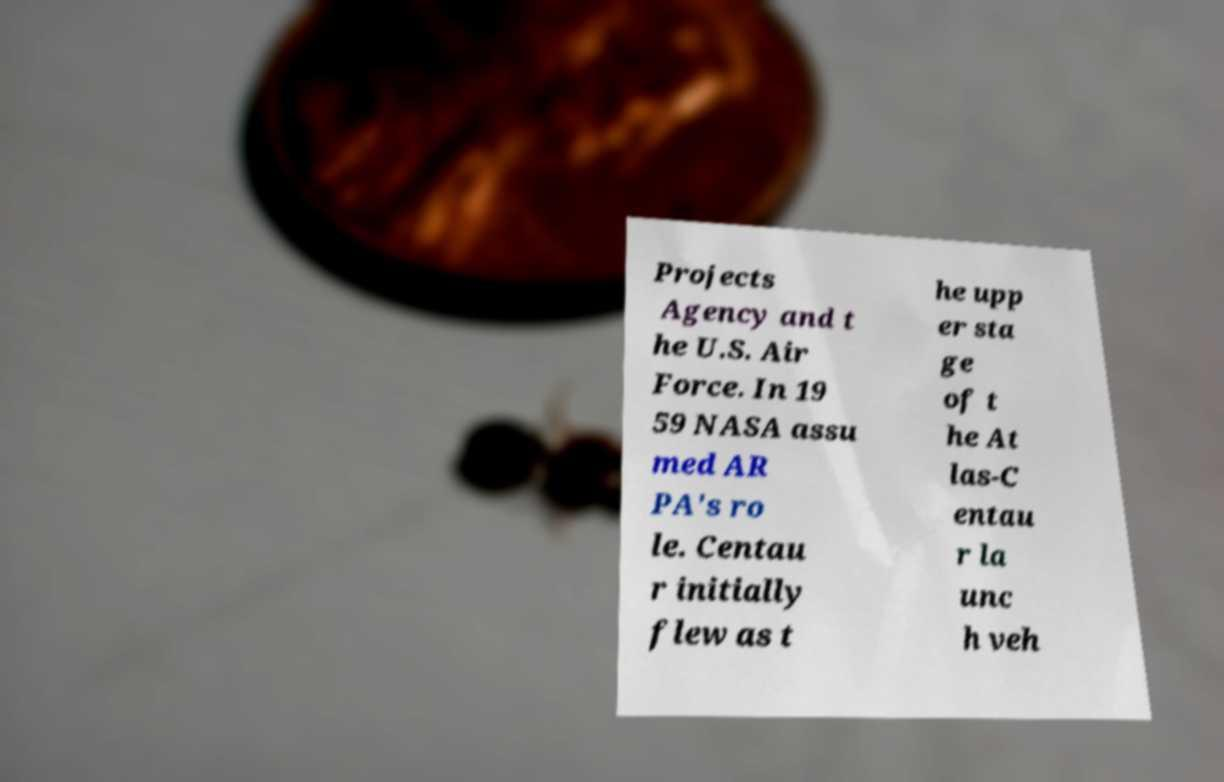I need the written content from this picture converted into text. Can you do that? Projects Agency and t he U.S. Air Force. In 19 59 NASA assu med AR PA's ro le. Centau r initially flew as t he upp er sta ge of t he At las-C entau r la unc h veh 